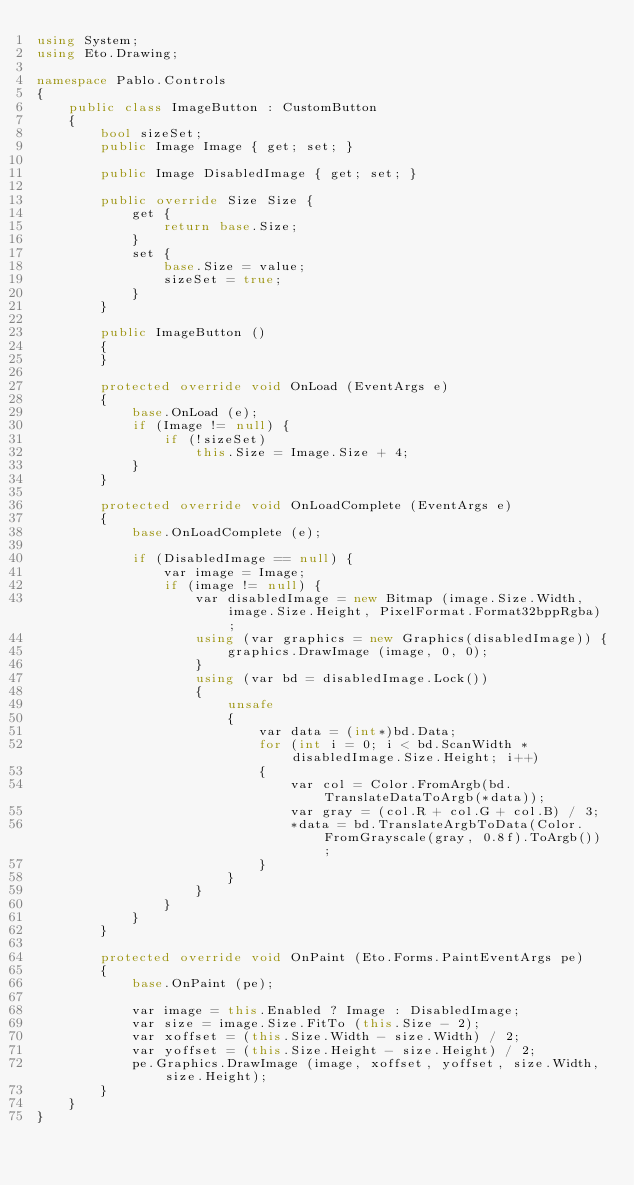Convert code to text. <code><loc_0><loc_0><loc_500><loc_500><_C#_>using System;
using Eto.Drawing;

namespace Pablo.Controls
{
	public class ImageButton : CustomButton
	{
		bool sizeSet;
		public Image Image { get; set; }

		public Image DisabledImage { get; set; }
		
		public override Size Size {
			get {
				return base.Size;
			}
			set {
				base.Size = value;
				sizeSet = true;
			}
		}
		
		public ImageButton ()
		{
		}
		
		protected override void OnLoad (EventArgs e)
		{
			base.OnLoad (e);
			if (Image != null) {
				if (!sizeSet)
					this.Size = Image.Size + 4;
			}
		}
		
		protected override void OnLoadComplete (EventArgs e)
		{
			base.OnLoadComplete (e);
			
			if (DisabledImage == null) {
				var image = Image;
				if (image != null) {
					var disabledImage = new Bitmap (image.Size.Width, image.Size.Height, PixelFormat.Format32bppRgba);
					using (var graphics = new Graphics(disabledImage)) {
						graphics.DrawImage (image, 0, 0);
					}
					using (var bd = disabledImage.Lock())
					{
						unsafe
						{
							var data = (int*)bd.Data;
							for (int i = 0; i < bd.ScanWidth * disabledImage.Size.Height; i++)
							{
								var col = Color.FromArgb(bd.TranslateDataToArgb(*data));
								var gray = (col.R + col.G + col.B) / 3;
								*data = bd.TranslateArgbToData(Color.FromGrayscale(gray, 0.8f).ToArgb());
							}
						}
					}
				}
			}
		}
		
		protected override void OnPaint (Eto.Forms.PaintEventArgs pe)
		{
			base.OnPaint (pe);
			
			var image = this.Enabled ? Image : DisabledImage;
			var size = image.Size.FitTo (this.Size - 2);
			var xoffset = (this.Size.Width - size.Width) / 2;
			var yoffset = (this.Size.Height - size.Height) / 2;
			pe.Graphics.DrawImage (image, xoffset, yoffset, size.Width, size.Height);
		}
	}
}

</code> 